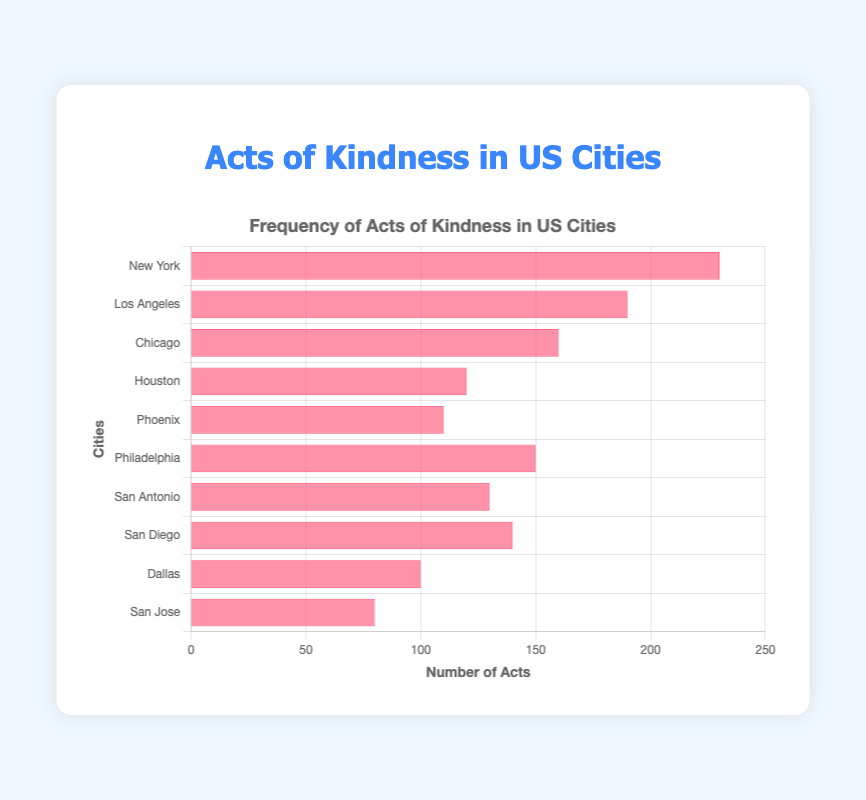Which city has the highest frequency of acts of kindness? The figure shows a horizontal bar chart with New York having the longest bar. New York has the highest frequency of acts of kindness, indicated as 230.
Answer: New York Which two cities have the lowest frequencies of acts of kindness? From the figure, the shortest bars represent San Jose and Dallas. San Jose has a frequency of 80, and Dallas has a frequency of 100.
Answer: San Jose and Dallas What is the difference in the frequency of acts of kindness between New York and Los Angeles? The frequency for New York is 230 and for Los Angeles is 190. The difference can be calculated as 230 - 190.
Answer: 40 What is the sum of kindness acts in San Diego and San Antonio? From the figure, San Diego has a frequency of 140 and San Antonio has a frequency of 130. The sum is 140 + 130.
Answer: 270 Which cities have a frequency of acts of kindness more than 150? The bars representing cities with a frequency above 150 are those that extend beyond the 150 mark. This includes New York, Los Angeles, and Chicago.
Answer: New York, Los Angeles, Chicago How many more acts of kindness are reported in Philadelphia than in Houston? The frequency of acts for Philadelphia is 150, and for Houston, it's 120. The difference is 150 - 120.
Answer: 30 What is the average frequency of acts of kindness across all cities? Sum all the frequencies: 230 (New York) + 190 (Los Angeles) + 160 (Chicago) + 120 (Houston) + 110 (Phoenix) + 150 (Philadelphia) + 130 (San Antonio) + 140 (San Diego) + 100 (Dallas) + 80 (San Jose) = 1410. Divide by the number of cities (10).
Answer: 141 Which city has a frequency closest to 150? Among the bar lengths around 150, Philadelphia has a frequency of 150.
Answer: Philadelphia How much higher is the frequency of acts of kindness in San Diego compared to Phoenix? San Diego has a frequency of 140, and Phoenix has a frequency of 110. The difference is 140 - 110.
Answer: 30 What is the median frequency of acts of kindness? Arrange the frequencies in ascending order: 80, 100, 110, 120, 130, 140, 150, 160, 190, 230. The median is the average of the 5th and 6th values: (130 + 140) / 2.
Answer: 135 